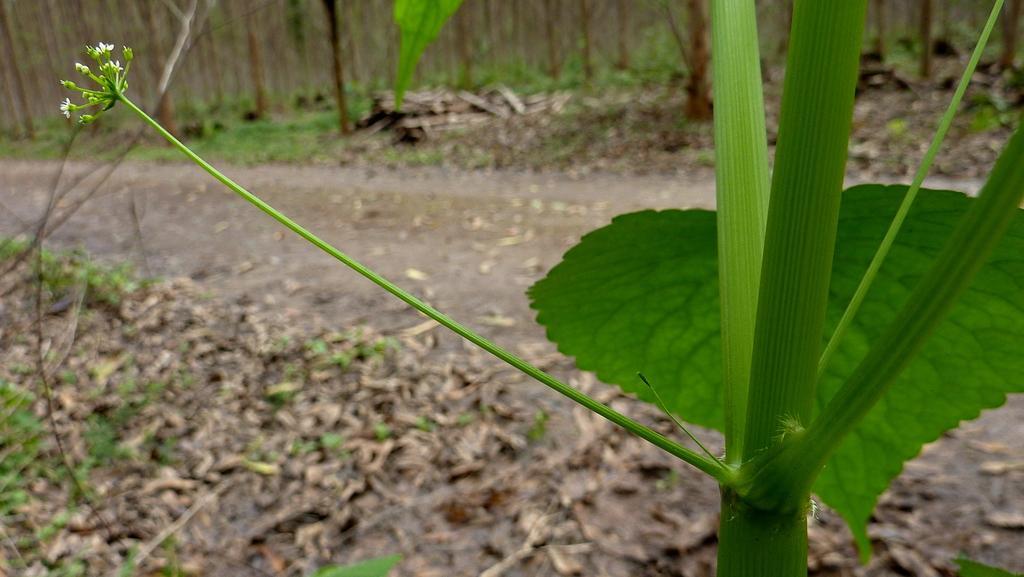Can you describe this image briefly? In this image I can see a plant which is green in color and few flowers to the plant which are white in color. In the background I can see the road, few leaves on the ground and few trees. I can see few wooden logs on the ground. 